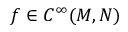Convert formula to latex. <formula><loc_0><loc_0><loc_500><loc_500>f \in C ^ { \infty } ( M , N )</formula> 